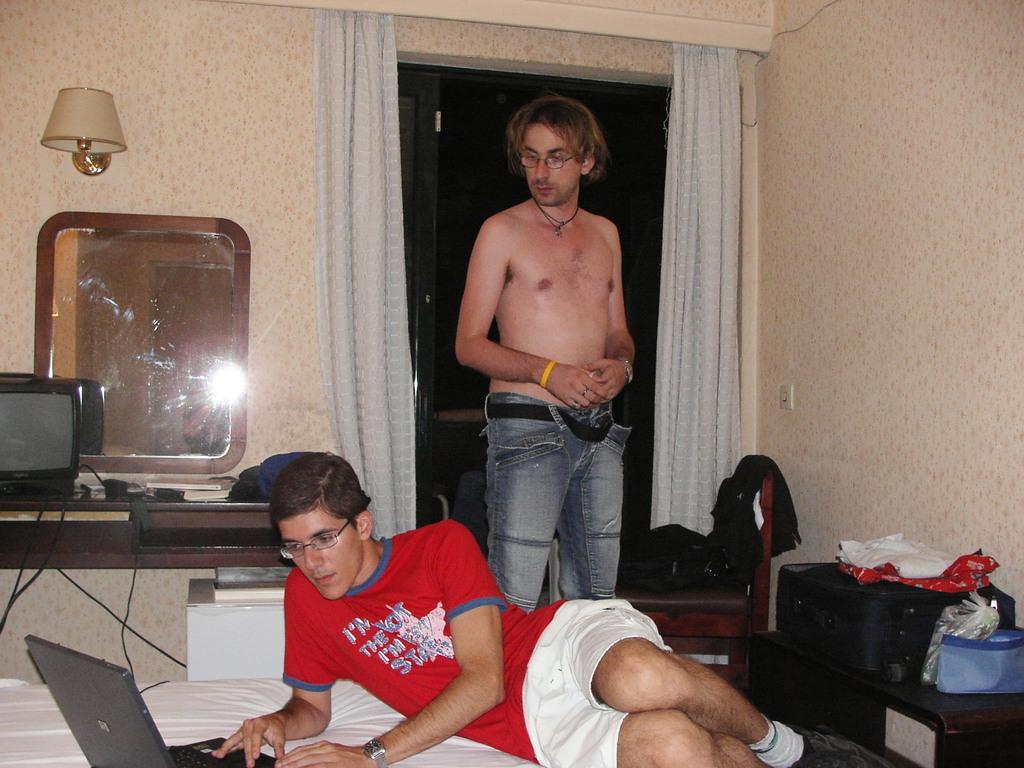Can you describe this image briefly? In this image we can see this person wearing red T-shirt, spectacles, shoes and watch is lying on the bed there is a laptop on it and we can see this person is standing on the floor. Here we can see the television, books, lamp, luggage bags, chair, curtains and the glass windows in the background. 